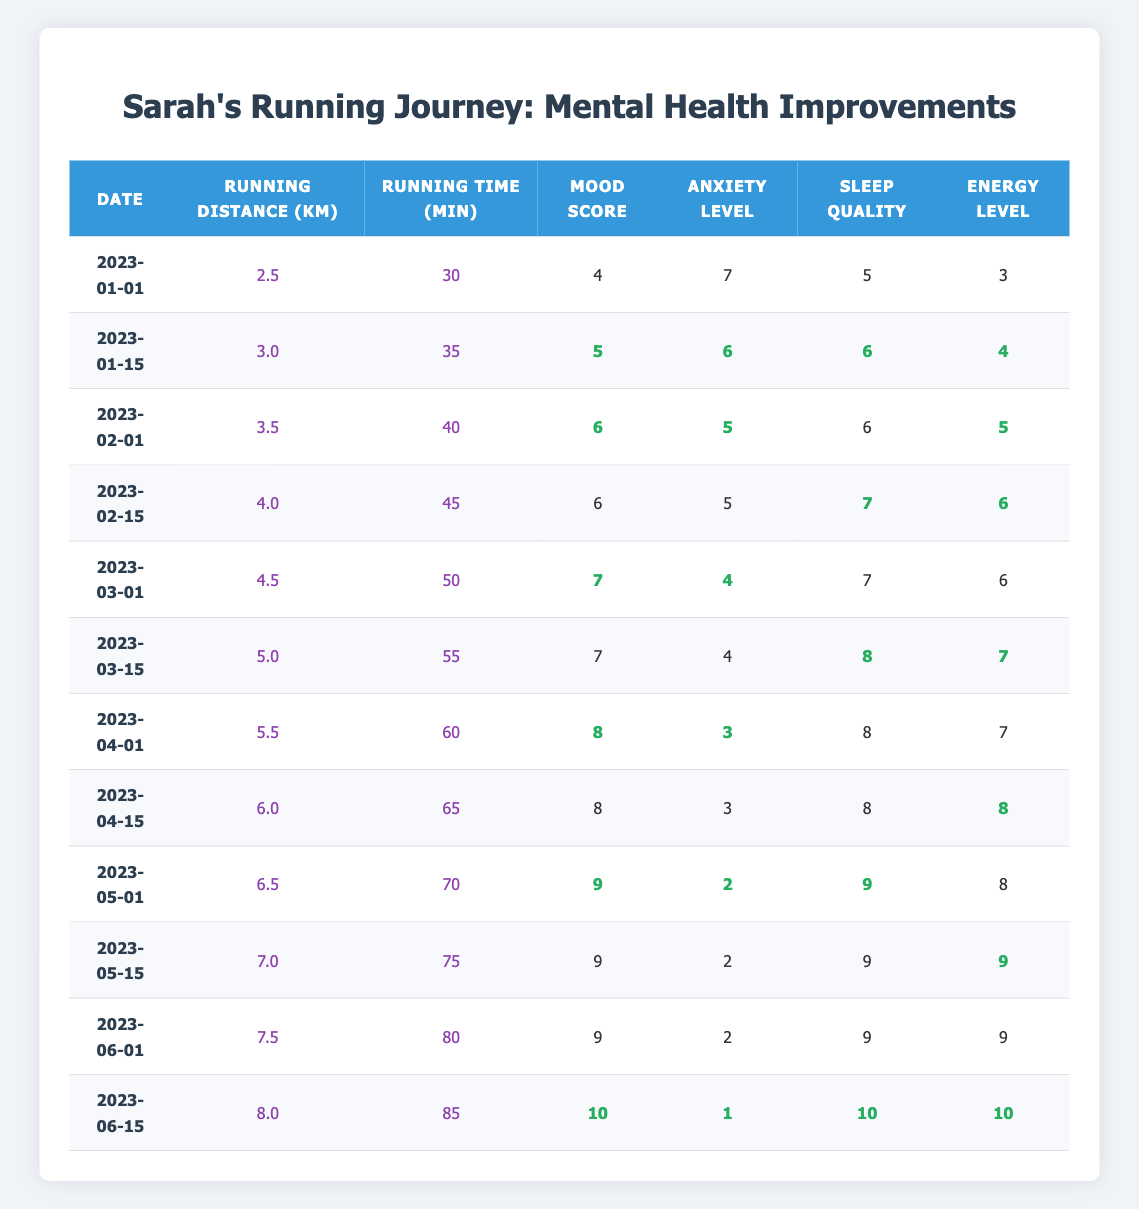What is Sarah's Mood Score on 2023-03-15? According to the table, on the date 2023-03-15, the Mood Score for Sarah is listed as 7.
Answer: 7 What was Sarah's Anxiety Level on 2023-05-01? From the data presented, on the date 2023-05-01, Sarah's Anxiety Level is recorded as 2.
Answer: 2 What is the average Sleep Quality over the entire six months? To find the average Sleep Quality, sum the Sleep Quality values: (5 + 6 + 6 + 7 + 7 + 8 + 8 + 8 + 9 + 9 + 9 + 10) = 81. There are 12 data points, so the average is 81/12 = 6.75.
Answer: 6.75 Did Sarah's Mood Score increase every two weeks? To assess this, check the Mood Scores: 4, 5, 6, 6, 7, 7, 8, 8, 9, 9, 9, 10. We see that the Mood Score did not increase between 2023-01-01 and 2023-02-01, and did not increase between 2023-02-01 and 2023-02-15. Therefore, the answer is no.
Answer: No What was the total running distance covered by Sarah from January to June? The total running distance amounts to: (2.5 + 3.0 + 3.5 + 4.0 + 4.5 + 5.0 + 5.5 + 6.0 + 6.5 + 7.0 + 7.5 + 8.0) = 60.0 km.
Answer: 60.0 km What was the change in Energy Level from the beginning to the end of the period? Energy Level on 2023-01-01 is 3, and on 2023-06-15 is 10. The change is 10 - 3 = 7.
Answer: 7 What is the highest Mood Score achieved by Sarah during this period? The highest Mood Score listed in the table is 10, recorded on 2023-06-15.
Answer: 10 How many times did Sarah run a distance greater than 6.0 km? According to the table, Sarah ran a distance greater than 6.0 km on three occasions: 6.5 km (2023-05-01), 7.0 km (2023-05-15), 7.5 km (2023-06-01), and 8.0 km (2023-06-15). Thus, the answer is 4 times.
Answer: 4 times What was the improvement in Sleep Quality from January 1 to June 15? Sleep Quality on 2023-01-01 is 5 and on 2023-06-15 is 10. The improvement is 10 - 5 = 5.
Answer: 5 